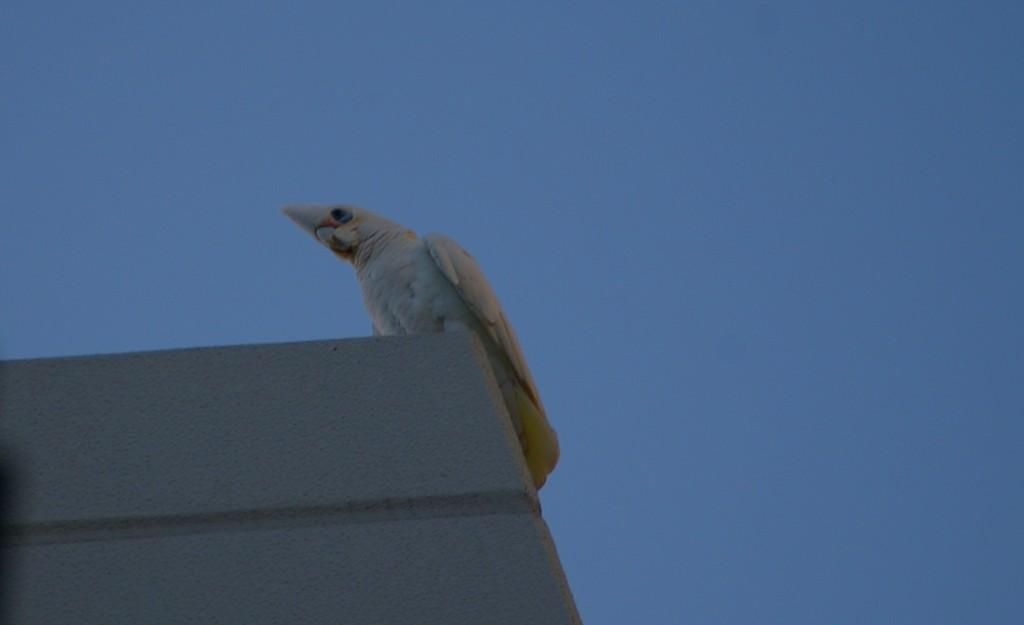What type of animal is present in the image? There is a bird in the image. What is the bird sitting on? The bird is on a white object. What color is the bird? The bird is white in color. What can be seen in the background of the image? There is a blue sky visible in the background of the image. What scientific discovery is the bird making in the image? There is no indication of a scientific discovery in the image; it simply features a white bird on a white object with a blue sky in the background. 